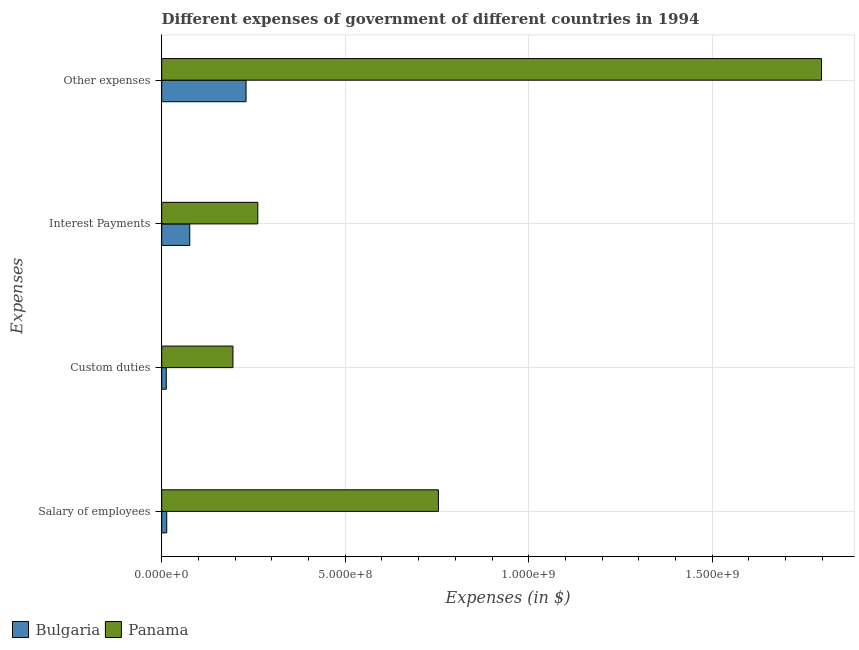How many groups of bars are there?
Your answer should be very brief. 4. Are the number of bars on each tick of the Y-axis equal?
Make the answer very short. Yes. What is the label of the 4th group of bars from the top?
Offer a terse response. Salary of employees. What is the amount spent on other expenses in Panama?
Give a very brief answer. 1.80e+09. Across all countries, what is the maximum amount spent on custom duties?
Provide a succinct answer. 1.94e+08. Across all countries, what is the minimum amount spent on custom duties?
Offer a terse response. 1.24e+07. In which country was the amount spent on custom duties maximum?
Offer a terse response. Panama. What is the total amount spent on interest payments in the graph?
Ensure brevity in your answer.  3.38e+08. What is the difference between the amount spent on custom duties in Panama and that in Bulgaria?
Provide a short and direct response. 1.82e+08. What is the difference between the amount spent on other expenses in Bulgaria and the amount spent on custom duties in Panama?
Give a very brief answer. 3.57e+07. What is the average amount spent on custom duties per country?
Offer a very short reply. 1.03e+08. What is the difference between the amount spent on other expenses and amount spent on custom duties in Bulgaria?
Keep it short and to the point. 2.17e+08. In how many countries, is the amount spent on salary of employees greater than 400000000 $?
Offer a very short reply. 1. What is the ratio of the amount spent on interest payments in Bulgaria to that in Panama?
Offer a terse response. 0.29. Is the amount spent on salary of employees in Bulgaria less than that in Panama?
Keep it short and to the point. Yes. What is the difference between the highest and the second highest amount spent on interest payments?
Your answer should be very brief. 1.85e+08. What is the difference between the highest and the lowest amount spent on salary of employees?
Offer a terse response. 7.40e+08. In how many countries, is the amount spent on salary of employees greater than the average amount spent on salary of employees taken over all countries?
Keep it short and to the point. 1. Is the sum of the amount spent on other expenses in Panama and Bulgaria greater than the maximum amount spent on custom duties across all countries?
Your answer should be compact. Yes. Is it the case that in every country, the sum of the amount spent on salary of employees and amount spent on other expenses is greater than the sum of amount spent on interest payments and amount spent on custom duties?
Offer a terse response. No. What does the 1st bar from the bottom in Other expenses represents?
Offer a terse response. Bulgaria. Is it the case that in every country, the sum of the amount spent on salary of employees and amount spent on custom duties is greater than the amount spent on interest payments?
Give a very brief answer. No. How many countries are there in the graph?
Provide a short and direct response. 2. What is the difference between two consecutive major ticks on the X-axis?
Provide a short and direct response. 5.00e+08. Does the graph contain any zero values?
Your answer should be very brief. No. Where does the legend appear in the graph?
Ensure brevity in your answer.  Bottom left. How many legend labels are there?
Make the answer very short. 2. What is the title of the graph?
Provide a short and direct response. Different expenses of government of different countries in 1994. Does "Namibia" appear as one of the legend labels in the graph?
Provide a short and direct response. No. What is the label or title of the X-axis?
Your answer should be compact. Expenses (in $). What is the label or title of the Y-axis?
Your response must be concise. Expenses. What is the Expenses (in $) in Bulgaria in Salary of employees?
Provide a short and direct response. 1.36e+07. What is the Expenses (in $) in Panama in Salary of employees?
Offer a very short reply. 7.54e+08. What is the Expenses (in $) in Bulgaria in Custom duties?
Your answer should be compact. 1.24e+07. What is the Expenses (in $) of Panama in Custom duties?
Your answer should be very brief. 1.94e+08. What is the Expenses (in $) in Bulgaria in Interest Payments?
Your answer should be very brief. 7.64e+07. What is the Expenses (in $) in Panama in Interest Payments?
Provide a succinct answer. 2.62e+08. What is the Expenses (in $) in Bulgaria in Other expenses?
Give a very brief answer. 2.30e+08. What is the Expenses (in $) of Panama in Other expenses?
Give a very brief answer. 1.80e+09. Across all Expenses, what is the maximum Expenses (in $) in Bulgaria?
Give a very brief answer. 2.30e+08. Across all Expenses, what is the maximum Expenses (in $) of Panama?
Keep it short and to the point. 1.80e+09. Across all Expenses, what is the minimum Expenses (in $) in Bulgaria?
Your response must be concise. 1.24e+07. Across all Expenses, what is the minimum Expenses (in $) in Panama?
Provide a short and direct response. 1.94e+08. What is the total Expenses (in $) of Bulgaria in the graph?
Ensure brevity in your answer.  3.32e+08. What is the total Expenses (in $) of Panama in the graph?
Offer a terse response. 3.01e+09. What is the difference between the Expenses (in $) of Bulgaria in Salary of employees and that in Custom duties?
Ensure brevity in your answer.  1.18e+06. What is the difference between the Expenses (in $) in Panama in Salary of employees and that in Custom duties?
Provide a succinct answer. 5.60e+08. What is the difference between the Expenses (in $) in Bulgaria in Salary of employees and that in Interest Payments?
Give a very brief answer. -6.28e+07. What is the difference between the Expenses (in $) in Panama in Salary of employees and that in Interest Payments?
Offer a very short reply. 4.92e+08. What is the difference between the Expenses (in $) of Bulgaria in Salary of employees and that in Other expenses?
Offer a terse response. -2.16e+08. What is the difference between the Expenses (in $) in Panama in Salary of employees and that in Other expenses?
Provide a short and direct response. -1.04e+09. What is the difference between the Expenses (in $) of Bulgaria in Custom duties and that in Interest Payments?
Your response must be concise. -6.40e+07. What is the difference between the Expenses (in $) of Panama in Custom duties and that in Interest Payments?
Ensure brevity in your answer.  -6.77e+07. What is the difference between the Expenses (in $) in Bulgaria in Custom duties and that in Other expenses?
Offer a very short reply. -2.17e+08. What is the difference between the Expenses (in $) of Panama in Custom duties and that in Other expenses?
Make the answer very short. -1.60e+09. What is the difference between the Expenses (in $) in Bulgaria in Interest Payments and that in Other expenses?
Keep it short and to the point. -1.53e+08. What is the difference between the Expenses (in $) of Panama in Interest Payments and that in Other expenses?
Give a very brief answer. -1.54e+09. What is the difference between the Expenses (in $) in Bulgaria in Salary of employees and the Expenses (in $) in Panama in Custom duties?
Your response must be concise. -1.80e+08. What is the difference between the Expenses (in $) of Bulgaria in Salary of employees and the Expenses (in $) of Panama in Interest Payments?
Your response must be concise. -2.48e+08. What is the difference between the Expenses (in $) of Bulgaria in Salary of employees and the Expenses (in $) of Panama in Other expenses?
Provide a short and direct response. -1.78e+09. What is the difference between the Expenses (in $) in Bulgaria in Custom duties and the Expenses (in $) in Panama in Interest Payments?
Keep it short and to the point. -2.49e+08. What is the difference between the Expenses (in $) of Bulgaria in Custom duties and the Expenses (in $) of Panama in Other expenses?
Provide a short and direct response. -1.79e+09. What is the difference between the Expenses (in $) of Bulgaria in Interest Payments and the Expenses (in $) of Panama in Other expenses?
Your answer should be compact. -1.72e+09. What is the average Expenses (in $) of Bulgaria per Expenses?
Make the answer very short. 8.31e+07. What is the average Expenses (in $) in Panama per Expenses?
Give a very brief answer. 7.52e+08. What is the difference between the Expenses (in $) of Bulgaria and Expenses (in $) of Panama in Salary of employees?
Give a very brief answer. -7.40e+08. What is the difference between the Expenses (in $) of Bulgaria and Expenses (in $) of Panama in Custom duties?
Keep it short and to the point. -1.82e+08. What is the difference between the Expenses (in $) in Bulgaria and Expenses (in $) in Panama in Interest Payments?
Offer a very short reply. -1.85e+08. What is the difference between the Expenses (in $) of Bulgaria and Expenses (in $) of Panama in Other expenses?
Provide a succinct answer. -1.57e+09. What is the ratio of the Expenses (in $) in Bulgaria in Salary of employees to that in Custom duties?
Your answer should be very brief. 1.1. What is the ratio of the Expenses (in $) of Panama in Salary of employees to that in Custom duties?
Keep it short and to the point. 3.88. What is the ratio of the Expenses (in $) in Bulgaria in Salary of employees to that in Interest Payments?
Ensure brevity in your answer.  0.18. What is the ratio of the Expenses (in $) in Panama in Salary of employees to that in Interest Payments?
Your response must be concise. 2.88. What is the ratio of the Expenses (in $) in Bulgaria in Salary of employees to that in Other expenses?
Provide a short and direct response. 0.06. What is the ratio of the Expenses (in $) in Panama in Salary of employees to that in Other expenses?
Your answer should be very brief. 0.42. What is the ratio of the Expenses (in $) in Bulgaria in Custom duties to that in Interest Payments?
Make the answer very short. 0.16. What is the ratio of the Expenses (in $) in Panama in Custom duties to that in Interest Payments?
Provide a succinct answer. 0.74. What is the ratio of the Expenses (in $) of Bulgaria in Custom duties to that in Other expenses?
Your answer should be compact. 0.05. What is the ratio of the Expenses (in $) of Panama in Custom duties to that in Other expenses?
Your response must be concise. 0.11. What is the ratio of the Expenses (in $) in Bulgaria in Interest Payments to that in Other expenses?
Make the answer very short. 0.33. What is the ratio of the Expenses (in $) in Panama in Interest Payments to that in Other expenses?
Provide a succinct answer. 0.15. What is the difference between the highest and the second highest Expenses (in $) of Bulgaria?
Provide a short and direct response. 1.53e+08. What is the difference between the highest and the second highest Expenses (in $) of Panama?
Keep it short and to the point. 1.04e+09. What is the difference between the highest and the lowest Expenses (in $) in Bulgaria?
Offer a terse response. 2.17e+08. What is the difference between the highest and the lowest Expenses (in $) of Panama?
Your answer should be compact. 1.60e+09. 